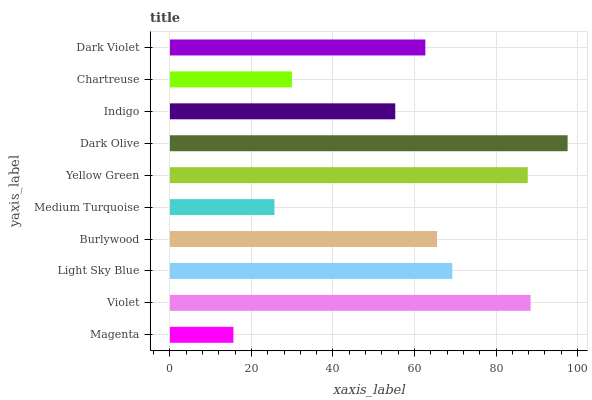Is Magenta the minimum?
Answer yes or no. Yes. Is Dark Olive the maximum?
Answer yes or no. Yes. Is Violet the minimum?
Answer yes or no. No. Is Violet the maximum?
Answer yes or no. No. Is Violet greater than Magenta?
Answer yes or no. Yes. Is Magenta less than Violet?
Answer yes or no. Yes. Is Magenta greater than Violet?
Answer yes or no. No. Is Violet less than Magenta?
Answer yes or no. No. Is Burlywood the high median?
Answer yes or no. Yes. Is Dark Violet the low median?
Answer yes or no. Yes. Is Medium Turquoise the high median?
Answer yes or no. No. Is Light Sky Blue the low median?
Answer yes or no. No. 